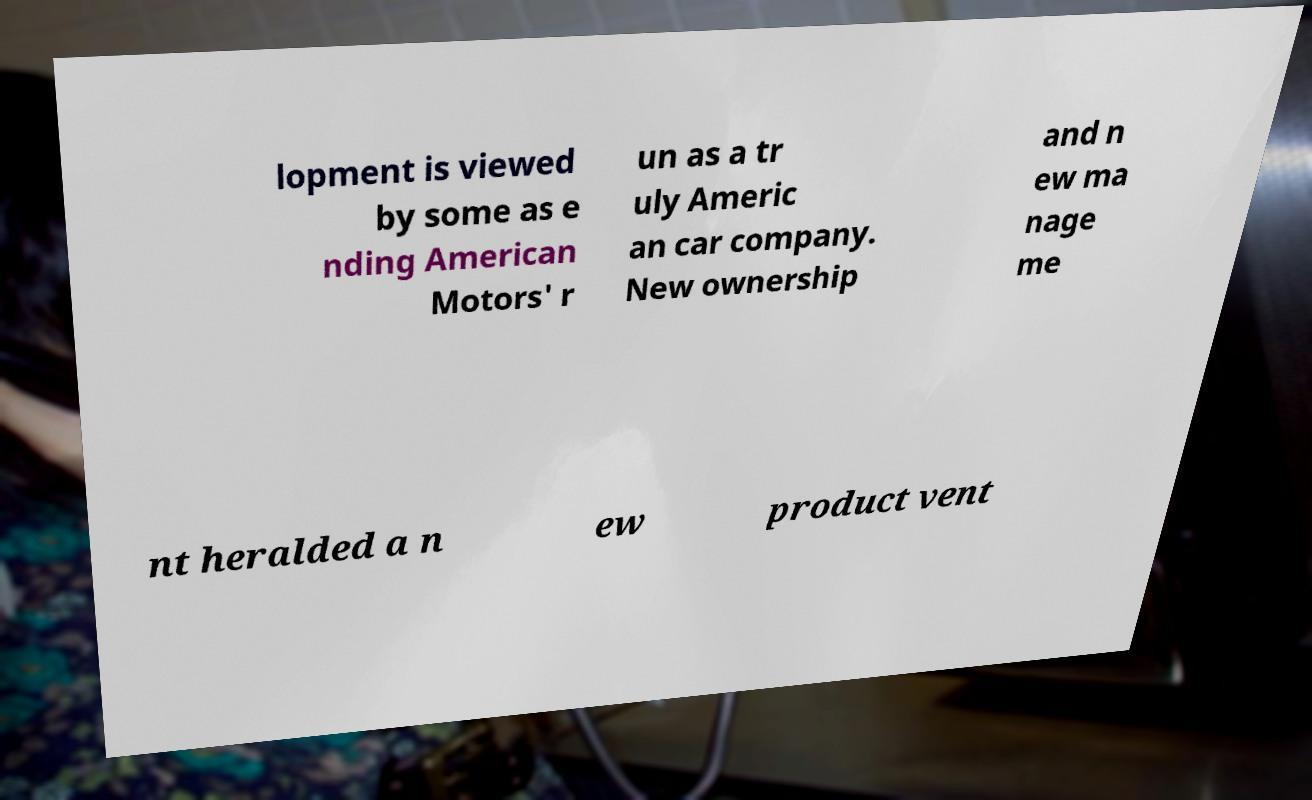Can you read and provide the text displayed in the image?This photo seems to have some interesting text. Can you extract and type it out for me? lopment is viewed by some as e nding American Motors' r un as a tr uly Americ an car company. New ownership and n ew ma nage me nt heralded a n ew product vent 